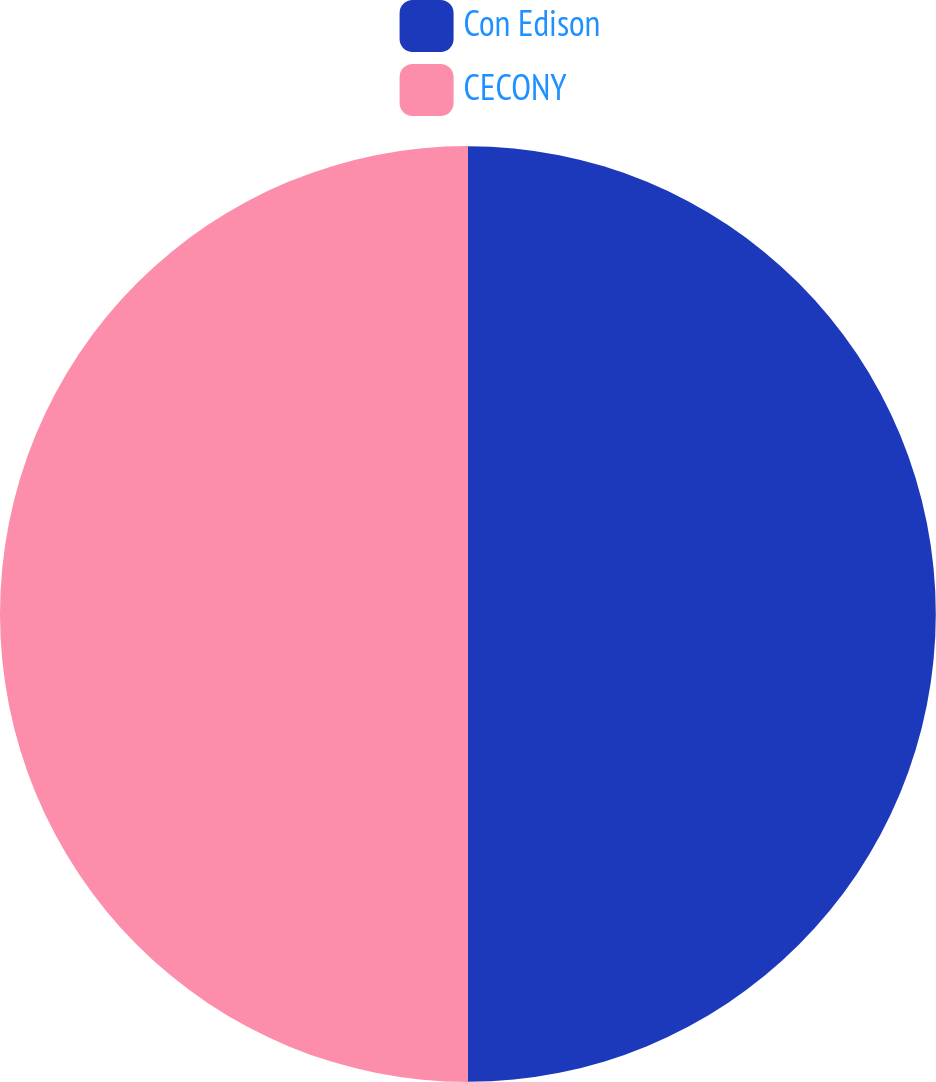Convert chart to OTSL. <chart><loc_0><loc_0><loc_500><loc_500><pie_chart><fcel>Con Edison<fcel>CECONY<nl><fcel>49.99%<fcel>50.01%<nl></chart> 